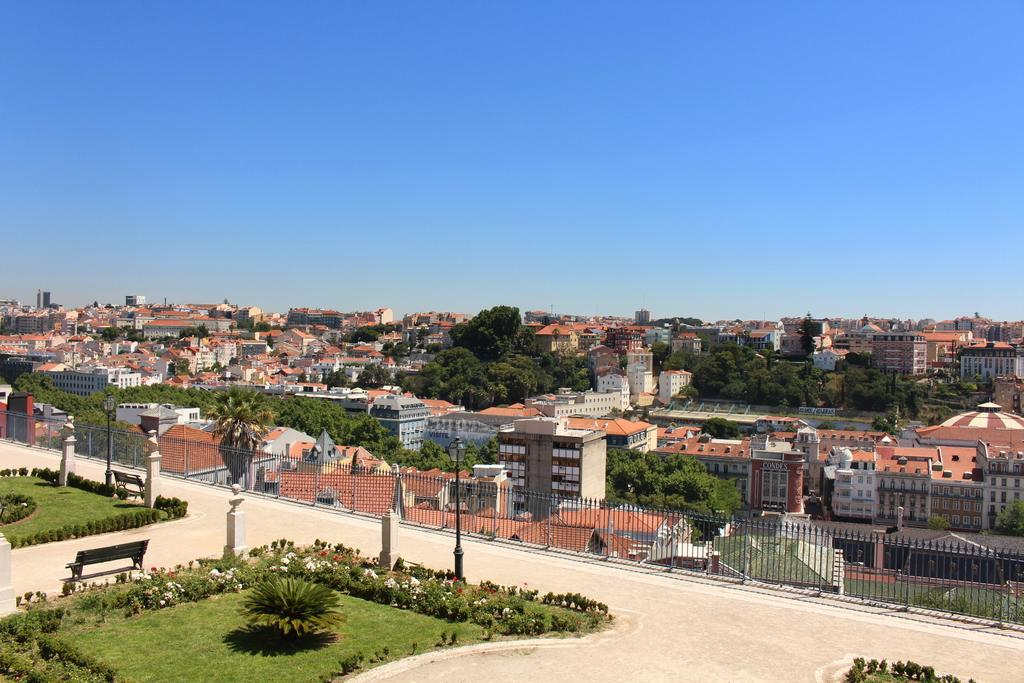What type of seating is visible in the image? There are benches in the image. What other objects can be seen in the image besides benches? There are plants, flowers, poles, and a fence in the background. Can you describe the vegetation in the image? There are plants and flowers visible in the image. What else can be seen in the background of the image? There are trees and buildings in the background. Where is the pot of soup located in the image? There is no pot of soup present in the image. What type of bomb is depicted in the image? There is no bomb present in the image. 